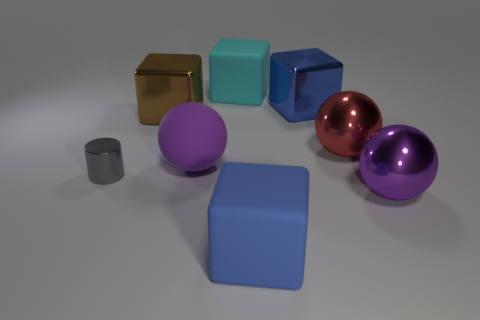Add 1 metal cylinders. How many objects exist? 9 Subtract all balls. How many objects are left? 5 Subtract 0 brown cylinders. How many objects are left? 8 Subtract all tiny cyan cylinders. Subtract all red metal things. How many objects are left? 7 Add 7 big blue matte things. How many big blue matte things are left? 8 Add 8 small blue matte objects. How many small blue matte objects exist? 8 